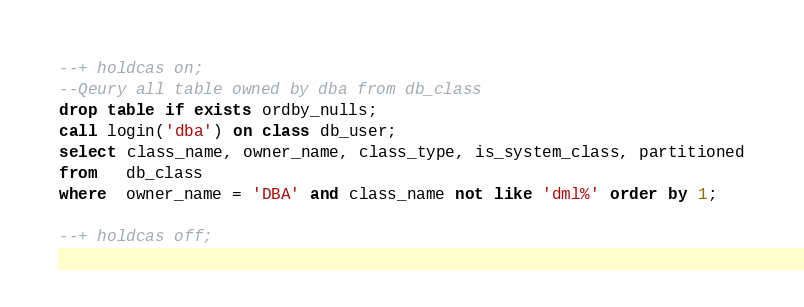<code> <loc_0><loc_0><loc_500><loc_500><_SQL_>--+ holdcas on;
--Qeury all table owned by dba from db_class
drop table if exists ordby_nulls;
call login('dba') on class db_user;
select class_name, owner_name, class_type, is_system_class, partitioned
from   db_class
where  owner_name = 'DBA' and class_name not like 'dml%' order by 1;

--+ holdcas off;
</code> 